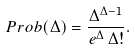Convert formula to latex. <formula><loc_0><loc_0><loc_500><loc_500>P r o b ( \Delta ) = \frac { \Delta ^ { \Delta - 1 } } { e ^ { \Delta } \, \Delta ! } .</formula> 